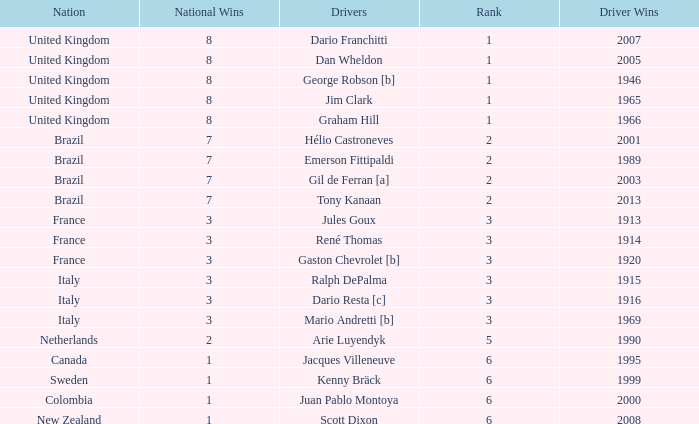What is the average number of wins of drivers from Sweden? 1999.0. Can you parse all the data within this table? {'header': ['Nation', 'National Wins', 'Drivers', 'Rank', 'Driver Wins'], 'rows': [['United Kingdom', '8', 'Dario Franchitti', '1', '2007'], ['United Kingdom', '8', 'Dan Wheldon', '1', '2005'], ['United Kingdom', '8', 'George Robson [b]', '1', '1946'], ['United Kingdom', '8', 'Jim Clark', '1', '1965'], ['United Kingdom', '8', 'Graham Hill', '1', '1966'], ['Brazil', '7', 'Hélio Castroneves', '2', '2001'], ['Brazil', '7', 'Emerson Fittipaldi', '2', '1989'], ['Brazil', '7', 'Gil de Ferran [a]', '2', '2003'], ['Brazil', '7', 'Tony Kanaan', '2', '2013'], ['France', '3', 'Jules Goux', '3', '1913'], ['France', '3', 'René Thomas', '3', '1914'], ['France', '3', 'Gaston Chevrolet [b]', '3', '1920'], ['Italy', '3', 'Ralph DePalma', '3', '1915'], ['Italy', '3', 'Dario Resta [c]', '3', '1916'], ['Italy', '3', 'Mario Andretti [b]', '3', '1969'], ['Netherlands', '2', 'Arie Luyendyk', '5', '1990'], ['Canada', '1', 'Jacques Villeneuve', '6', '1995'], ['Sweden', '1', 'Kenny Bräck', '6', '1999'], ['Colombia', '1', 'Juan Pablo Montoya', '6', '2000'], ['New Zealand', '1', 'Scott Dixon', '6', '2008']]} 